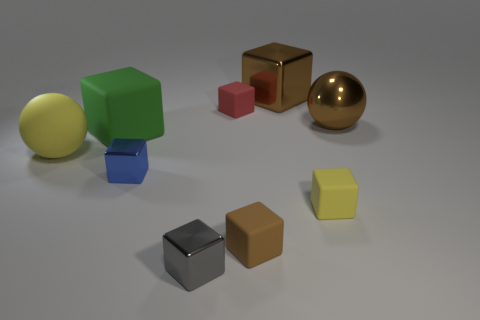How many other things are there of the same material as the tiny brown thing?
Give a very brief answer. 4. Is the number of metallic objects that are behind the brown sphere greater than the number of big brown shiny objects that are in front of the big yellow matte object?
Your answer should be very brief. Yes. There is a brown block that is behind the tiny brown thing; what is it made of?
Your answer should be compact. Metal. Do the large yellow object and the blue metal thing have the same shape?
Provide a succinct answer. No. Are there any other things that are the same color as the big matte cube?
Ensure brevity in your answer.  No. There is a large metal thing that is the same shape as the tiny brown object; what color is it?
Give a very brief answer. Brown. Are there more red cubes that are right of the small brown matte cube than brown matte objects?
Give a very brief answer. No. What color is the large block that is left of the small blue metal cube?
Offer a very short reply. Green. Is the red cube the same size as the yellow rubber sphere?
Offer a terse response. No. What is the size of the rubber sphere?
Your answer should be compact. Large. 